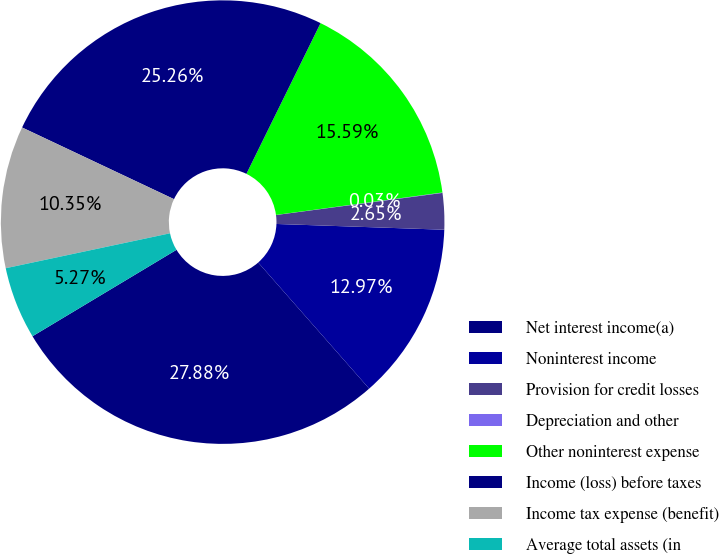Convert chart to OTSL. <chart><loc_0><loc_0><loc_500><loc_500><pie_chart><fcel>Net interest income(a)<fcel>Noninterest income<fcel>Provision for credit losses<fcel>Depreciation and other<fcel>Other noninterest expense<fcel>Income (loss) before taxes<fcel>Income tax expense (benefit)<fcel>Average total assets (in<nl><fcel>27.88%<fcel>12.97%<fcel>2.65%<fcel>0.03%<fcel>15.59%<fcel>25.26%<fcel>10.35%<fcel>5.27%<nl></chart> 